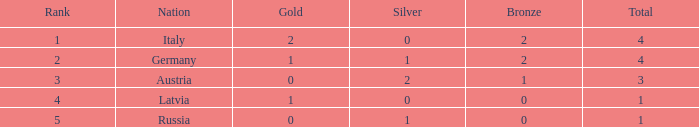What is the average number of silver medals for countries with 0 gold and rank under 3? None. Could you parse the entire table? {'header': ['Rank', 'Nation', 'Gold', 'Silver', 'Bronze', 'Total'], 'rows': [['1', 'Italy', '2', '0', '2', '4'], ['2', 'Germany', '1', '1', '2', '4'], ['3', 'Austria', '0', '2', '1', '3'], ['4', 'Latvia', '1', '0', '0', '1'], ['5', 'Russia', '0', '1', '0', '1']]} 